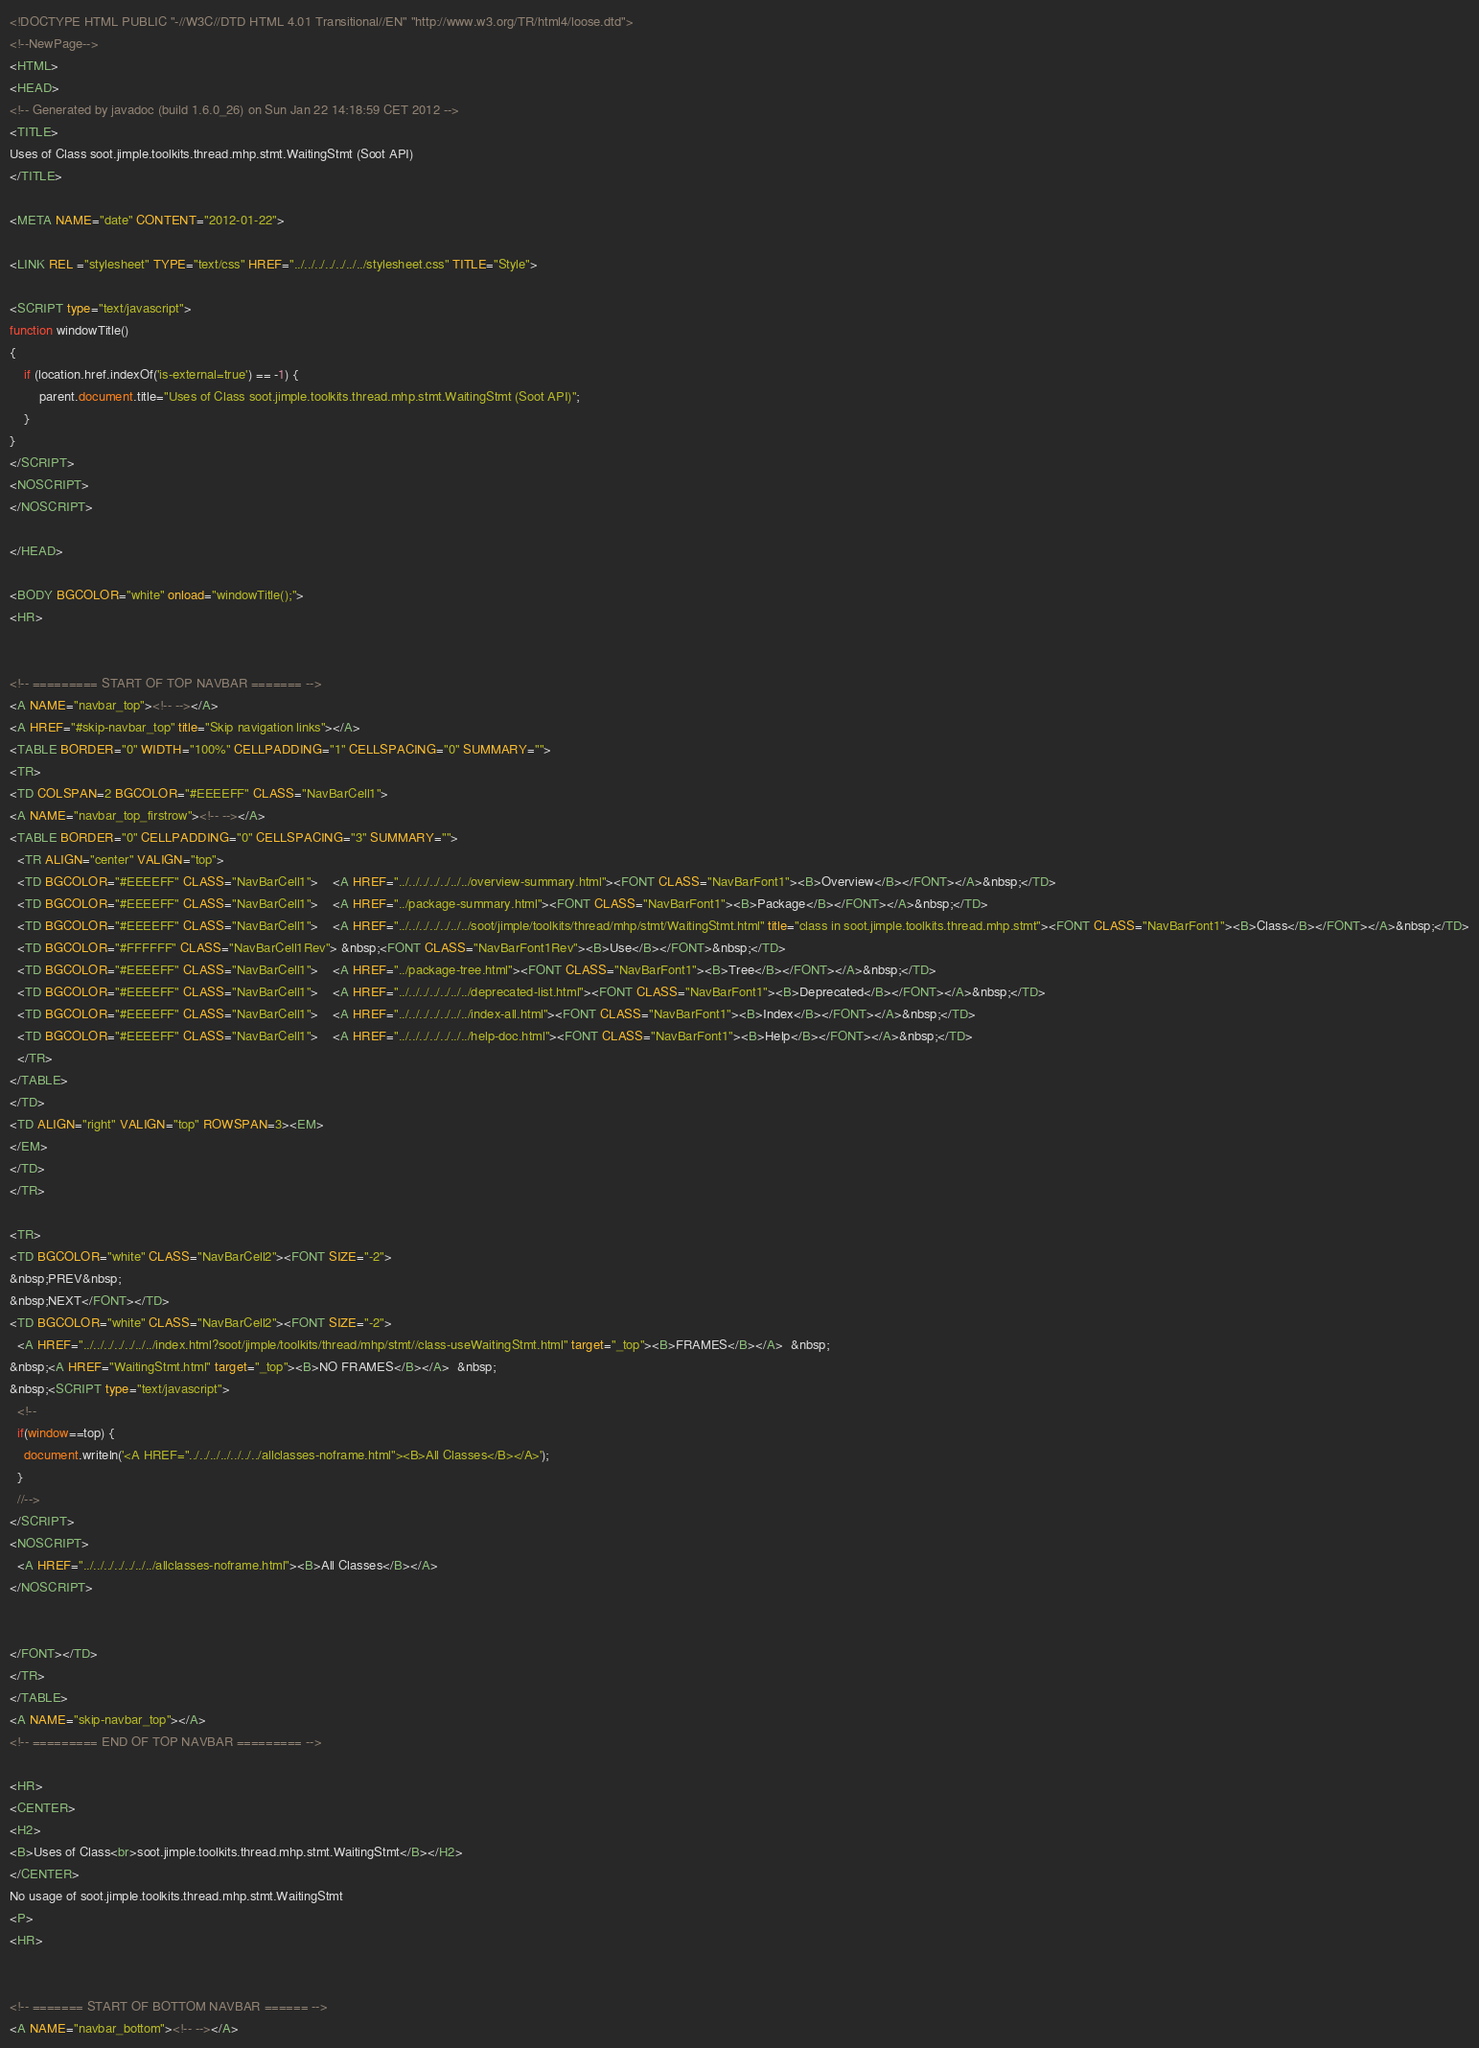<code> <loc_0><loc_0><loc_500><loc_500><_HTML_><!DOCTYPE HTML PUBLIC "-//W3C//DTD HTML 4.01 Transitional//EN" "http://www.w3.org/TR/html4/loose.dtd">
<!--NewPage-->
<HTML>
<HEAD>
<!-- Generated by javadoc (build 1.6.0_26) on Sun Jan 22 14:18:59 CET 2012 -->
<TITLE>
Uses of Class soot.jimple.toolkits.thread.mhp.stmt.WaitingStmt (Soot API)
</TITLE>

<META NAME="date" CONTENT="2012-01-22">

<LINK REL ="stylesheet" TYPE="text/css" HREF="../../../../../../../stylesheet.css" TITLE="Style">

<SCRIPT type="text/javascript">
function windowTitle()
{
    if (location.href.indexOf('is-external=true') == -1) {
        parent.document.title="Uses of Class soot.jimple.toolkits.thread.mhp.stmt.WaitingStmt (Soot API)";
    }
}
</SCRIPT>
<NOSCRIPT>
</NOSCRIPT>

</HEAD>

<BODY BGCOLOR="white" onload="windowTitle();">
<HR>


<!-- ========= START OF TOP NAVBAR ======= -->
<A NAME="navbar_top"><!-- --></A>
<A HREF="#skip-navbar_top" title="Skip navigation links"></A>
<TABLE BORDER="0" WIDTH="100%" CELLPADDING="1" CELLSPACING="0" SUMMARY="">
<TR>
<TD COLSPAN=2 BGCOLOR="#EEEEFF" CLASS="NavBarCell1">
<A NAME="navbar_top_firstrow"><!-- --></A>
<TABLE BORDER="0" CELLPADDING="0" CELLSPACING="3" SUMMARY="">
  <TR ALIGN="center" VALIGN="top">
  <TD BGCOLOR="#EEEEFF" CLASS="NavBarCell1">    <A HREF="../../../../../../../overview-summary.html"><FONT CLASS="NavBarFont1"><B>Overview</B></FONT></A>&nbsp;</TD>
  <TD BGCOLOR="#EEEEFF" CLASS="NavBarCell1">    <A HREF="../package-summary.html"><FONT CLASS="NavBarFont1"><B>Package</B></FONT></A>&nbsp;</TD>
  <TD BGCOLOR="#EEEEFF" CLASS="NavBarCell1">    <A HREF="../../../../../../../soot/jimple/toolkits/thread/mhp/stmt/WaitingStmt.html" title="class in soot.jimple.toolkits.thread.mhp.stmt"><FONT CLASS="NavBarFont1"><B>Class</B></FONT></A>&nbsp;</TD>
  <TD BGCOLOR="#FFFFFF" CLASS="NavBarCell1Rev"> &nbsp;<FONT CLASS="NavBarFont1Rev"><B>Use</B></FONT>&nbsp;</TD>
  <TD BGCOLOR="#EEEEFF" CLASS="NavBarCell1">    <A HREF="../package-tree.html"><FONT CLASS="NavBarFont1"><B>Tree</B></FONT></A>&nbsp;</TD>
  <TD BGCOLOR="#EEEEFF" CLASS="NavBarCell1">    <A HREF="../../../../../../../deprecated-list.html"><FONT CLASS="NavBarFont1"><B>Deprecated</B></FONT></A>&nbsp;</TD>
  <TD BGCOLOR="#EEEEFF" CLASS="NavBarCell1">    <A HREF="../../../../../../../index-all.html"><FONT CLASS="NavBarFont1"><B>Index</B></FONT></A>&nbsp;</TD>
  <TD BGCOLOR="#EEEEFF" CLASS="NavBarCell1">    <A HREF="../../../../../../../help-doc.html"><FONT CLASS="NavBarFont1"><B>Help</B></FONT></A>&nbsp;</TD>
  </TR>
</TABLE>
</TD>
<TD ALIGN="right" VALIGN="top" ROWSPAN=3><EM>
</EM>
</TD>
</TR>

<TR>
<TD BGCOLOR="white" CLASS="NavBarCell2"><FONT SIZE="-2">
&nbsp;PREV&nbsp;
&nbsp;NEXT</FONT></TD>
<TD BGCOLOR="white" CLASS="NavBarCell2"><FONT SIZE="-2">
  <A HREF="../../../../../../../index.html?soot/jimple/toolkits/thread/mhp/stmt//class-useWaitingStmt.html" target="_top"><B>FRAMES</B></A>  &nbsp;
&nbsp;<A HREF="WaitingStmt.html" target="_top"><B>NO FRAMES</B></A>  &nbsp;
&nbsp;<SCRIPT type="text/javascript">
  <!--
  if(window==top) {
    document.writeln('<A HREF="../../../../../../../allclasses-noframe.html"><B>All Classes</B></A>');
  }
  //-->
</SCRIPT>
<NOSCRIPT>
  <A HREF="../../../../../../../allclasses-noframe.html"><B>All Classes</B></A>
</NOSCRIPT>


</FONT></TD>
</TR>
</TABLE>
<A NAME="skip-navbar_top"></A>
<!-- ========= END OF TOP NAVBAR ========= -->

<HR>
<CENTER>
<H2>
<B>Uses of Class<br>soot.jimple.toolkits.thread.mhp.stmt.WaitingStmt</B></H2>
</CENTER>
No usage of soot.jimple.toolkits.thread.mhp.stmt.WaitingStmt
<P>
<HR>


<!-- ======= START OF BOTTOM NAVBAR ====== -->
<A NAME="navbar_bottom"><!-- --></A></code> 